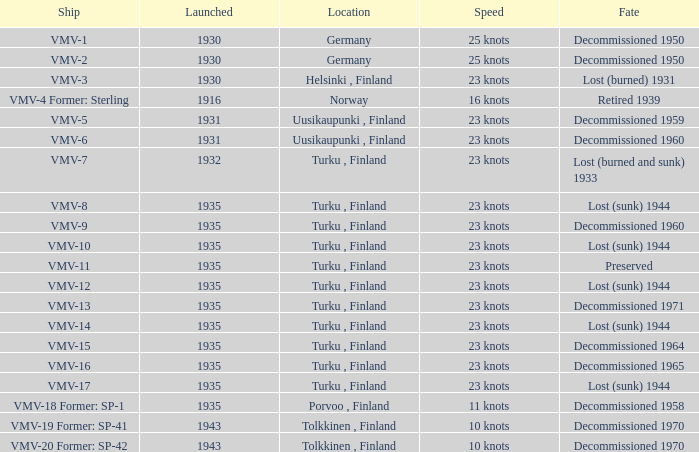What is the average launch date of the vmv-1 vessel in Germany? 1930.0. 